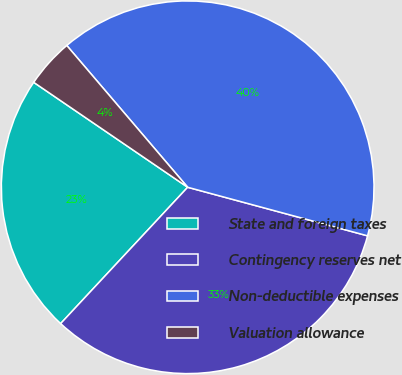<chart> <loc_0><loc_0><loc_500><loc_500><pie_chart><fcel>State and foreign taxes<fcel>Contingency reserves net<fcel>Non-deductible expenses<fcel>Valuation allowance<nl><fcel>22.58%<fcel>32.74%<fcel>40.43%<fcel>4.24%<nl></chart> 